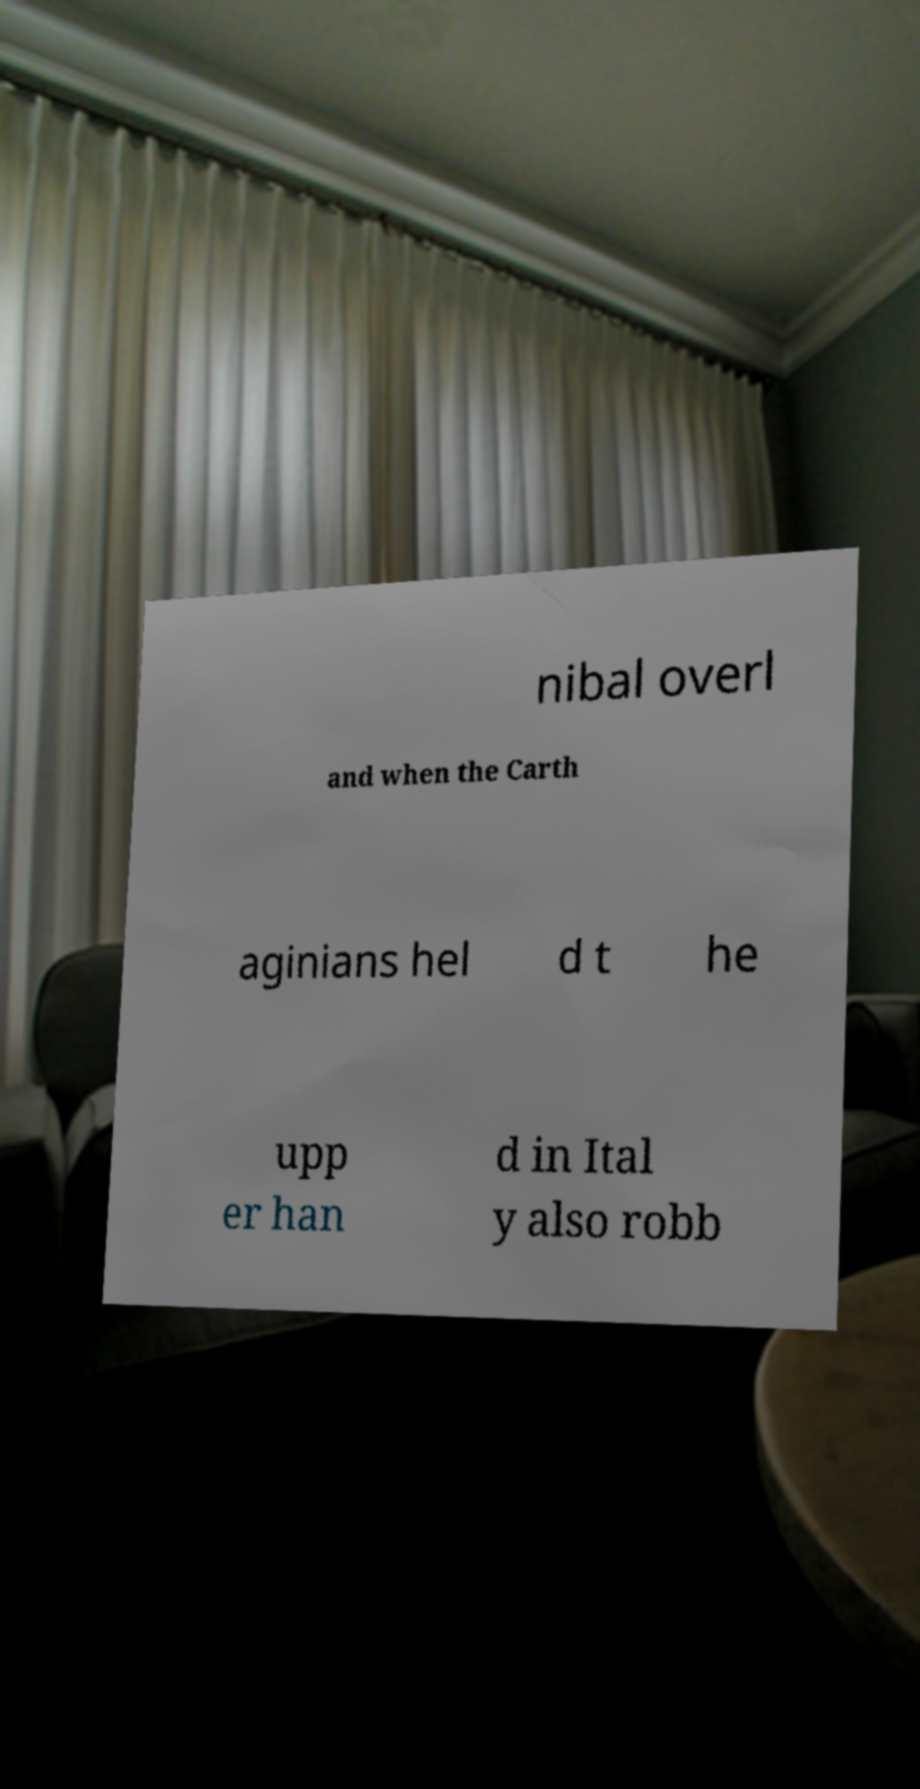Please read and relay the text visible in this image. What does it say? nibal overl and when the Carth aginians hel d t he upp er han d in Ital y also robb 